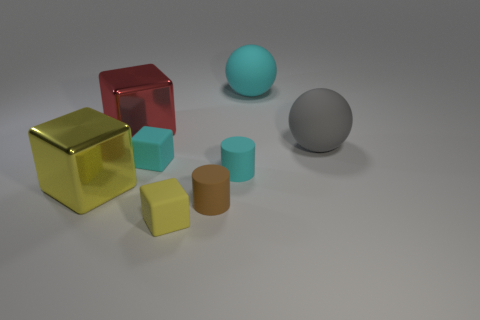Is there a block that has the same size as the brown rubber cylinder?
Your answer should be very brief. Yes. How many objects are both to the right of the large yellow shiny cube and in front of the cyan sphere?
Your answer should be compact. 6. How many large gray rubber balls are in front of the tiny yellow rubber block?
Provide a short and direct response. 0. Are there any other tiny rubber objects that have the same shape as the gray thing?
Offer a very short reply. No. There is a yellow metal object; is it the same shape as the big metal thing behind the big yellow thing?
Your response must be concise. Yes. How many cylinders are large gray matte things or tiny yellow matte things?
Give a very brief answer. 0. The red shiny object that is on the left side of the large gray sphere has what shape?
Offer a very short reply. Cube. How many large objects are the same material as the large gray ball?
Give a very brief answer. 1. Are there fewer brown matte cylinders that are left of the small cyan matte block than big cyan things?
Ensure brevity in your answer.  Yes. There is a block that is to the right of the small matte cube behind the small yellow block; what is its size?
Make the answer very short. Small. 